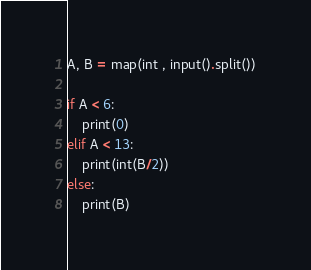Convert code to text. <code><loc_0><loc_0><loc_500><loc_500><_Python_>A, B = map(int , input().split())

if A < 6:
    print(0)
elif A < 13:
    print(int(B/2))
else:
    print(B)</code> 